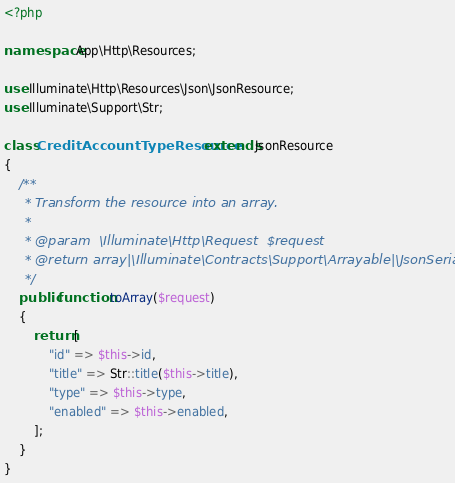Convert code to text. <code><loc_0><loc_0><loc_500><loc_500><_PHP_><?php

namespace App\Http\Resources;

use Illuminate\Http\Resources\Json\JsonResource;
use Illuminate\Support\Str;

class CreditAccountTypeResource extends JsonResource
{
    /**
     * Transform the resource into an array.
     *
     * @param  \Illuminate\Http\Request  $request
     * @return array|\Illuminate\Contracts\Support\Arrayable|\JsonSerializable
     */
    public function toArray($request)
    {
        return [
            "id" => $this->id,
            "title" => Str::title($this->title),
            "type" => $this->type,
            "enabled" => $this->enabled,
        ];
    }
}
</code> 